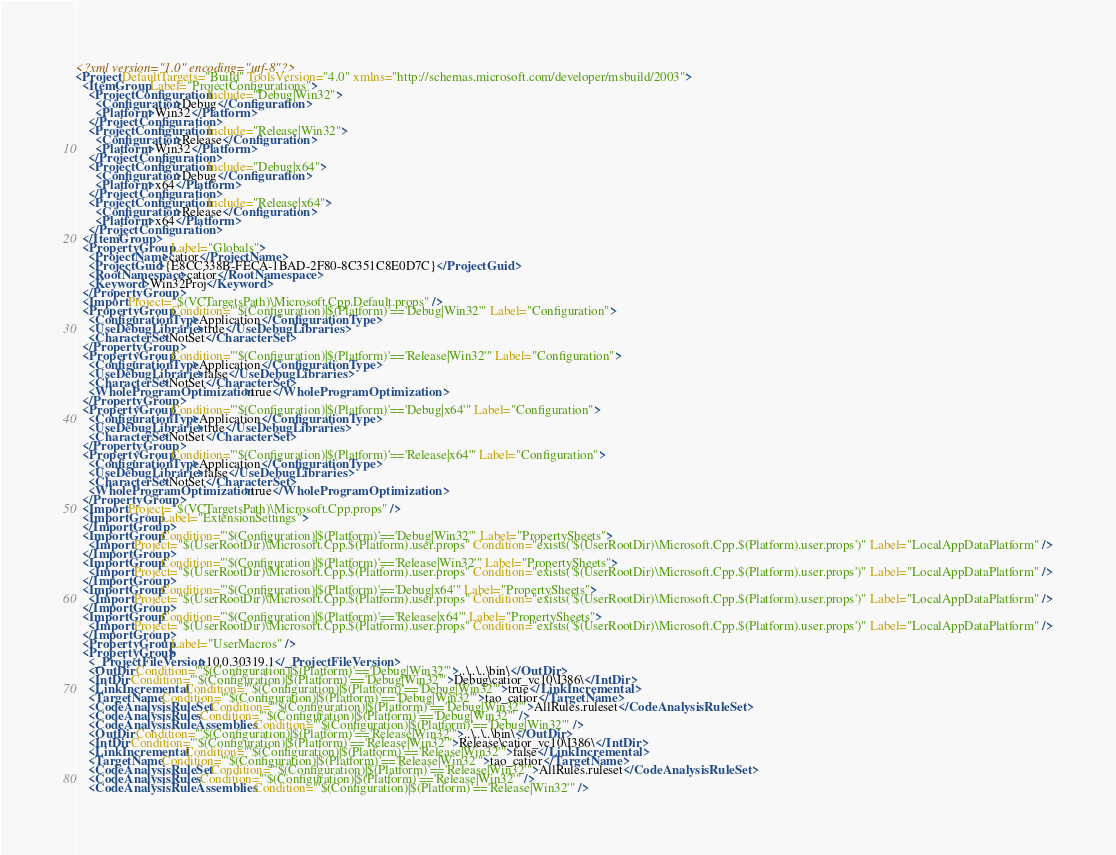<code> <loc_0><loc_0><loc_500><loc_500><_XML_><?xml version="1.0" encoding="utf-8"?>
<Project DefaultTargets="Build" ToolsVersion="4.0" xmlns="http://schemas.microsoft.com/developer/msbuild/2003">
  <ItemGroup Label="ProjectConfigurations">
    <ProjectConfiguration Include="Debug|Win32">
      <Configuration>Debug</Configuration>
      <Platform>Win32</Platform>
    </ProjectConfiguration>
    <ProjectConfiguration Include="Release|Win32">
      <Configuration>Release</Configuration>
      <Platform>Win32</Platform>
    </ProjectConfiguration>
    <ProjectConfiguration Include="Debug|x64">
      <Configuration>Debug</Configuration>
      <Platform>x64</Platform>
    </ProjectConfiguration>
    <ProjectConfiguration Include="Release|x64">
      <Configuration>Release</Configuration>
      <Platform>x64</Platform>
    </ProjectConfiguration>
  </ItemGroup>
  <PropertyGroup Label="Globals">
    <ProjectName>catior</ProjectName>
    <ProjectGuid>{E8CC338B-FECA-1BAD-2F80-8C351C8E0D7C}</ProjectGuid>
    <RootNamespace>catior</RootNamespace>
    <Keyword>Win32Proj</Keyword>
  </PropertyGroup>
  <Import Project="$(VCTargetsPath)\Microsoft.Cpp.Default.props" />
  <PropertyGroup Condition="'$(Configuration)|$(Platform)'=='Debug|Win32'" Label="Configuration">
    <ConfigurationType>Application</ConfigurationType>
    <UseDebugLibraries>true</UseDebugLibraries>
    <CharacterSet>NotSet</CharacterSet>
  </PropertyGroup>
  <PropertyGroup Condition="'$(Configuration)|$(Platform)'=='Release|Win32'" Label="Configuration">
    <ConfigurationType>Application</ConfigurationType>
    <UseDebugLibraries>false</UseDebugLibraries>
    <CharacterSet>NotSet</CharacterSet>
    <WholeProgramOptimization>true</WholeProgramOptimization>
  </PropertyGroup>
  <PropertyGroup Condition="'$(Configuration)|$(Platform)'=='Debug|x64'" Label="Configuration">
    <ConfigurationType>Application</ConfigurationType>
    <UseDebugLibraries>true</UseDebugLibraries>
    <CharacterSet>NotSet</CharacterSet>
  </PropertyGroup>
  <PropertyGroup Condition="'$(Configuration)|$(Platform)'=='Release|x64'" Label="Configuration">
    <ConfigurationType>Application</ConfigurationType>
    <UseDebugLibraries>false</UseDebugLibraries>
    <CharacterSet>NotSet</CharacterSet>
    <WholeProgramOptimization>true</WholeProgramOptimization>
  </PropertyGroup>
  <Import Project="$(VCTargetsPath)\Microsoft.Cpp.props" />
  <ImportGroup Label="ExtensionSettings">
  </ImportGroup>
  <ImportGroup Condition="'$(Configuration)|$(Platform)'=='Debug|Win32'" Label="PropertySheets">
    <Import Project="$(UserRootDir)\Microsoft.Cpp.$(Platform).user.props" Condition="exists('$(UserRootDir)\Microsoft.Cpp.$(Platform).user.props')" Label="LocalAppDataPlatform" />
  </ImportGroup>
  <ImportGroup Condition="'$(Configuration)|$(Platform)'=='Release|Win32'" Label="PropertySheets">
    <Import Project="$(UserRootDir)\Microsoft.Cpp.$(Platform).user.props" Condition="exists('$(UserRootDir)\Microsoft.Cpp.$(Platform).user.props')" Label="LocalAppDataPlatform" />
  </ImportGroup>
  <ImportGroup Condition="'$(Configuration)|$(Platform)'=='Debug|x64'" Label="PropertySheets">
    <Import Project="$(UserRootDir)\Microsoft.Cpp.$(Platform).user.props" Condition="exists('$(UserRootDir)\Microsoft.Cpp.$(Platform).user.props')" Label="LocalAppDataPlatform" />
  </ImportGroup>
  <ImportGroup Condition="'$(Configuration)|$(Platform)'=='Release|x64'" Label="PropertySheets">
    <Import Project="$(UserRootDir)\Microsoft.Cpp.$(Platform).user.props" Condition="exists('$(UserRootDir)\Microsoft.Cpp.$(Platform).user.props')" Label="LocalAppDataPlatform" />
  </ImportGroup>
  <PropertyGroup Label="UserMacros" />
  <PropertyGroup>
    <_ProjectFileVersion>10.0.30319.1</_ProjectFileVersion>
    <OutDir Condition="'$(Configuration)|$(Platform)'=='Debug|Win32'">..\..\..\bin\</OutDir>
    <IntDir Condition="'$(Configuration)|$(Platform)'=='Debug|Win32'">Debug\catior_vc10\I386\</IntDir>
    <LinkIncremental Condition="'$(Configuration)|$(Platform)'=='Debug|Win32'">true</LinkIncremental>
    <TargetName Condition="'$(Configuration)|$(Platform)'=='Debug|Win32'">tao_catior</TargetName>
    <CodeAnalysisRuleSet Condition="'$(Configuration)|$(Platform)'=='Debug|Win32'">AllRules.ruleset</CodeAnalysisRuleSet>
    <CodeAnalysisRules Condition="'$(Configuration)|$(Platform)'=='Debug|Win32'" />
    <CodeAnalysisRuleAssemblies Condition="'$(Configuration)|$(Platform)'=='Debug|Win32'" />
    <OutDir Condition="'$(Configuration)|$(Platform)'=='Release|Win32'">..\..\..\bin\</OutDir>
    <IntDir Condition="'$(Configuration)|$(Platform)'=='Release|Win32'">Release\catior_vc10\I386\</IntDir>
    <LinkIncremental Condition="'$(Configuration)|$(Platform)'=='Release|Win32'">false</LinkIncremental>
    <TargetName Condition="'$(Configuration)|$(Platform)'=='Release|Win32'">tao_catior</TargetName>
    <CodeAnalysisRuleSet Condition="'$(Configuration)|$(Platform)'=='Release|Win32'">AllRules.ruleset</CodeAnalysisRuleSet>
    <CodeAnalysisRules Condition="'$(Configuration)|$(Platform)'=='Release|Win32'" />
    <CodeAnalysisRuleAssemblies Condition="'$(Configuration)|$(Platform)'=='Release|Win32'" /></code> 